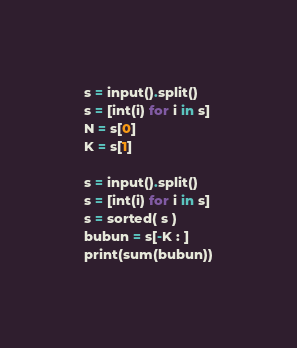Convert code to text. <code><loc_0><loc_0><loc_500><loc_500><_Python_>s = input().split()
s = [int(i) for i in s]
N = s[0]
K = s[1]

s = input().split()
s = [int(i) for i in s]
s = sorted( s )
bubun = s[-K : ]
print(sum(bubun))
</code> 